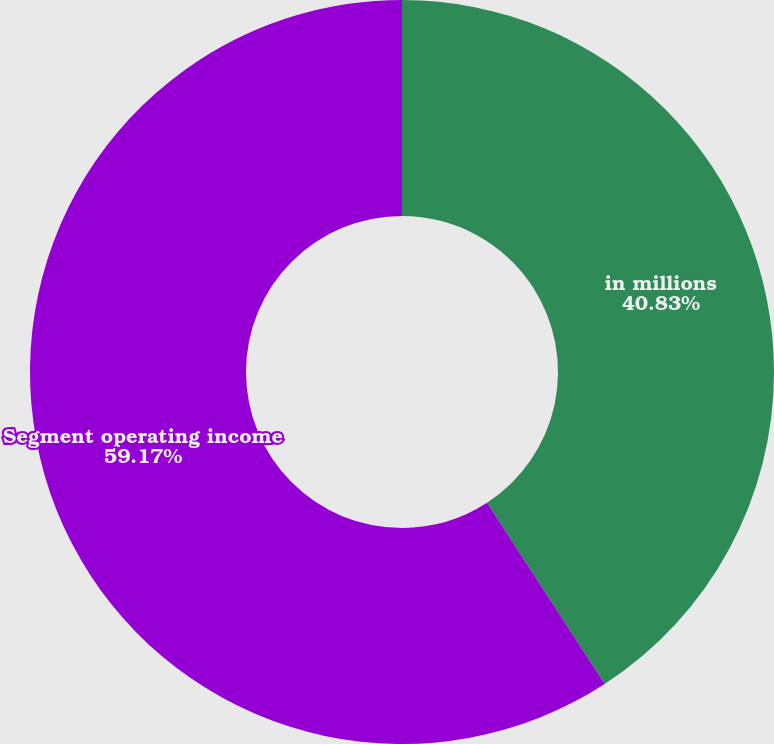Convert chart to OTSL. <chart><loc_0><loc_0><loc_500><loc_500><pie_chart><fcel>in millions<fcel>Segment operating income<nl><fcel>40.83%<fcel>59.17%<nl></chart> 